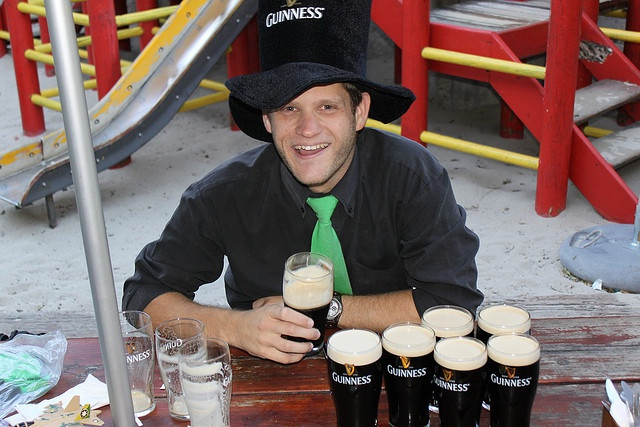Describe the objects in this image and their specific colors. I can see people in darkgray, black, tan, and gray tones, cup in darkgray, black, lightgray, and tan tones, cup in darkgray, black, lightgray, beige, and gray tones, cup in darkgray, black, lightgray, and tan tones, and cup in darkgray, black, beige, and tan tones in this image. 